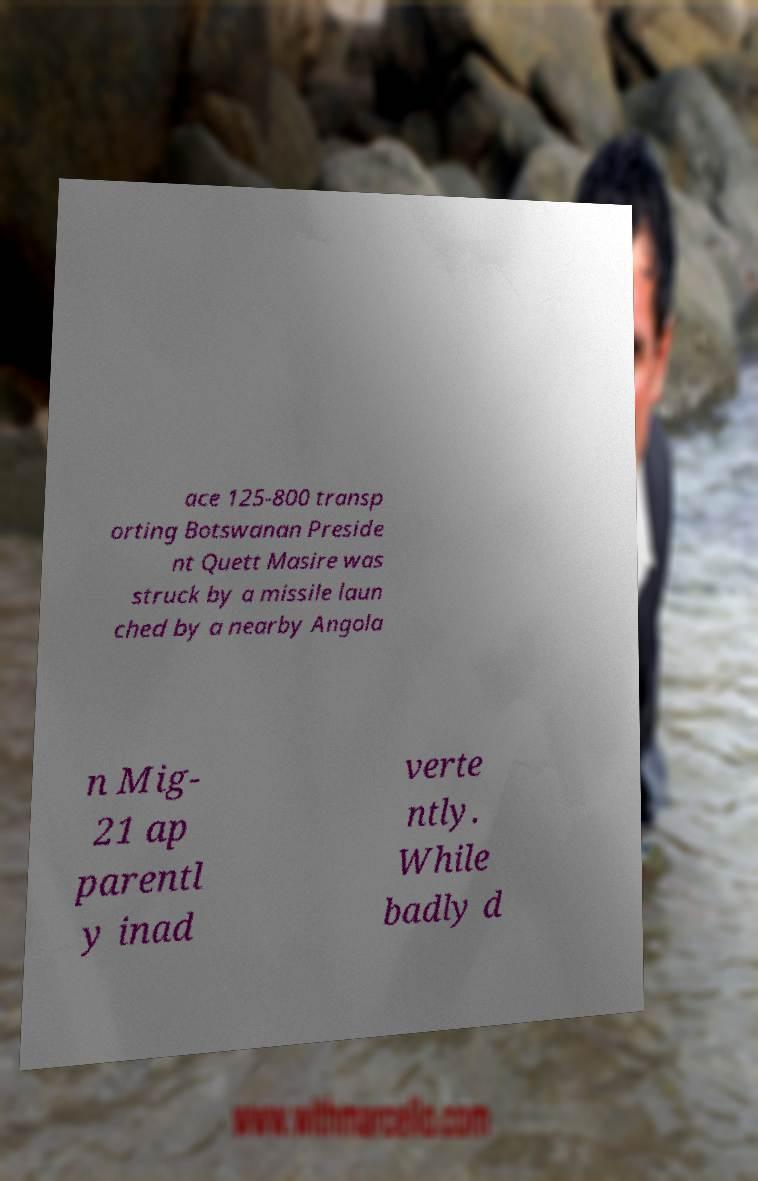Please read and relay the text visible in this image. What does it say? ace 125-800 transp orting Botswanan Preside nt Quett Masire was struck by a missile laun ched by a nearby Angola n Mig- 21 ap parentl y inad verte ntly. While badly d 